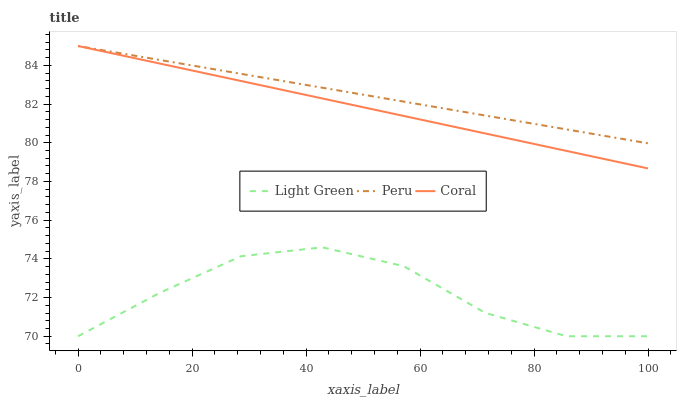Does Light Green have the minimum area under the curve?
Answer yes or no. Yes. Does Peru have the maximum area under the curve?
Answer yes or no. Yes. Does Peru have the minimum area under the curve?
Answer yes or no. No. Does Light Green have the maximum area under the curve?
Answer yes or no. No. Is Peru the smoothest?
Answer yes or no. Yes. Is Light Green the roughest?
Answer yes or no. Yes. Is Light Green the smoothest?
Answer yes or no. No. Is Peru the roughest?
Answer yes or no. No. Does Peru have the lowest value?
Answer yes or no. No. Does Peru have the highest value?
Answer yes or no. Yes. Does Light Green have the highest value?
Answer yes or no. No. Is Light Green less than Coral?
Answer yes or no. Yes. Is Coral greater than Light Green?
Answer yes or no. Yes. Does Coral intersect Peru?
Answer yes or no. Yes. Is Coral less than Peru?
Answer yes or no. No. Is Coral greater than Peru?
Answer yes or no. No. Does Light Green intersect Coral?
Answer yes or no. No. 